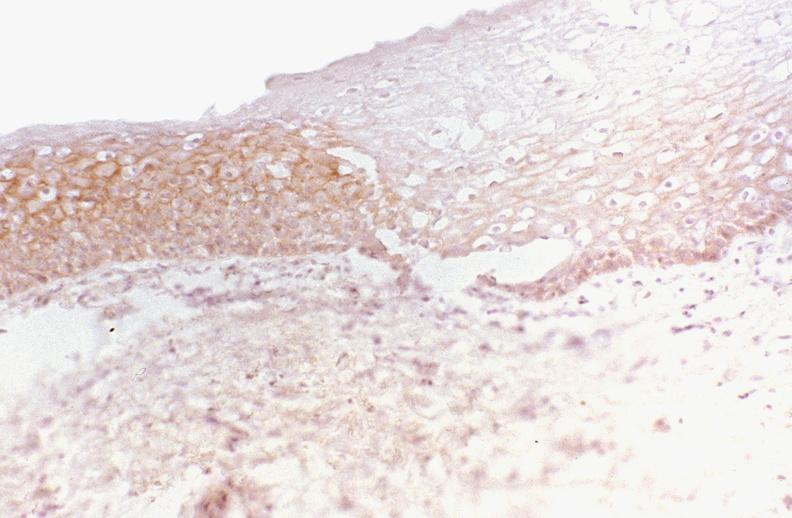s this image shows of smooth muscle cell with lipid in sarcoplasm and lipid present?
Answer the question using a single word or phrase. No 